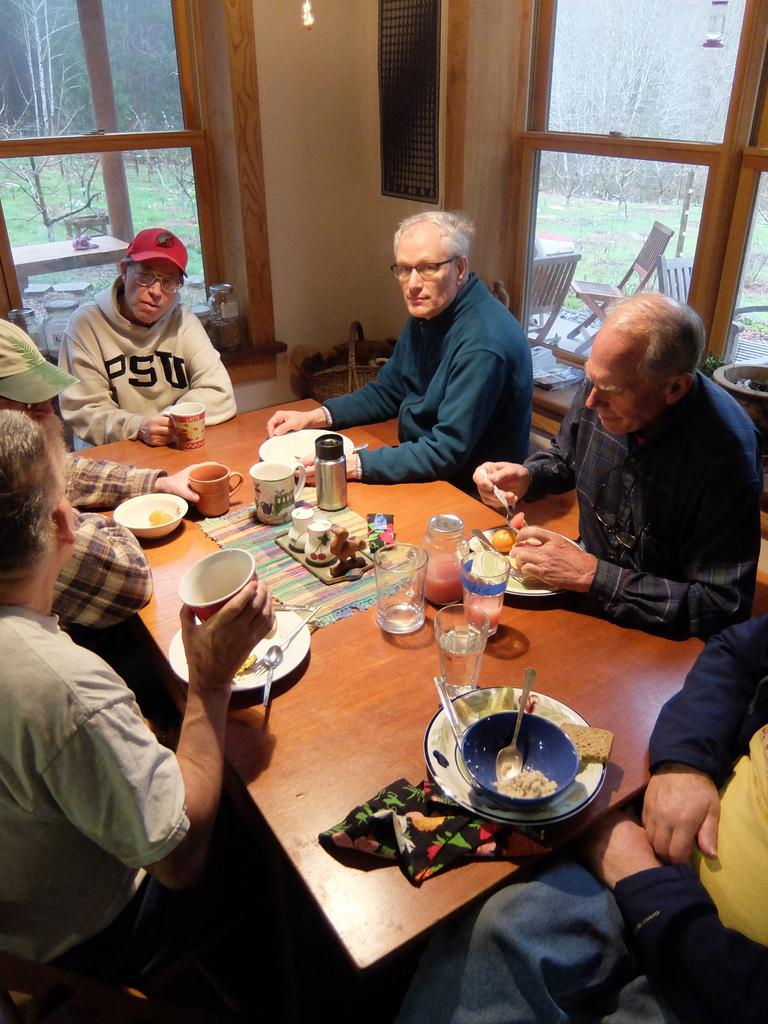What are the people in the image doing? The people in the image are sitting around a table. What objects can be seen on the table? There are glasses, mugs, and plates on the table. What type of furniture is present in the image? There are chairs in the image. What can be seen in the background of the image? Trees are visible in the image. What color is the skirt worn by the person sitting at the table? There is no person wearing a skirt in the image. How many ants can be seen crawling on the table in the image? There are no ants present in the image. 